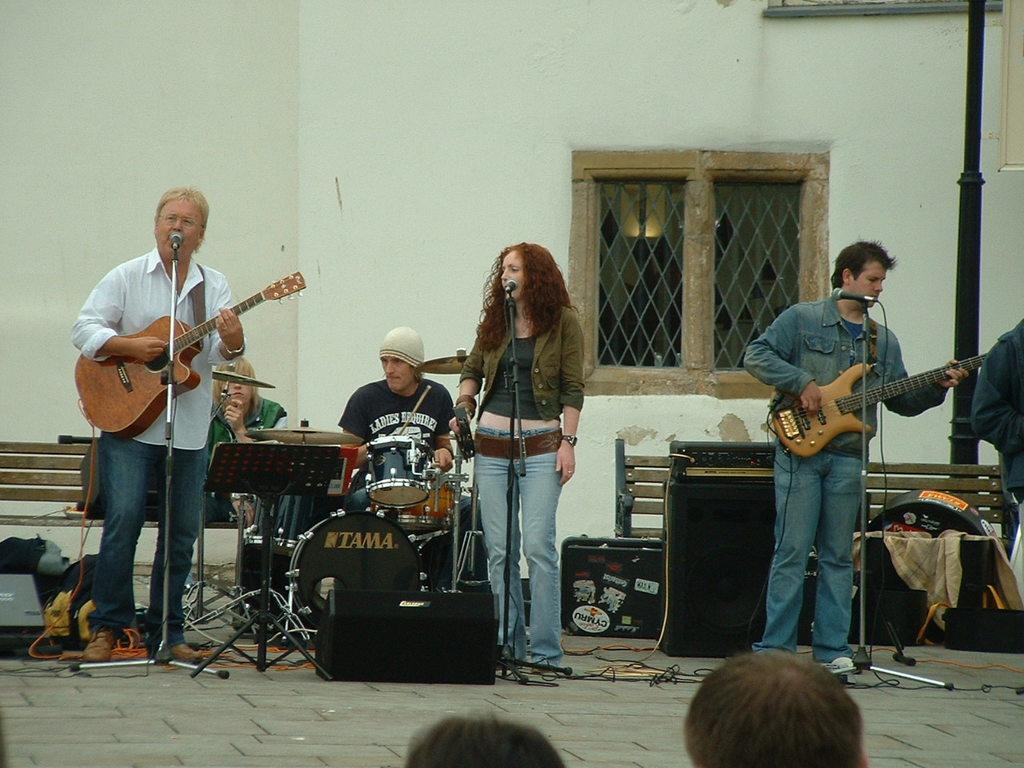Can you describe this image briefly? There are a group of people who are at a place with some musical instruments among them there are standing in front of the mics and two are holding the guitars and the other guy is sitting and playing an instrument and there is a window behind them. 